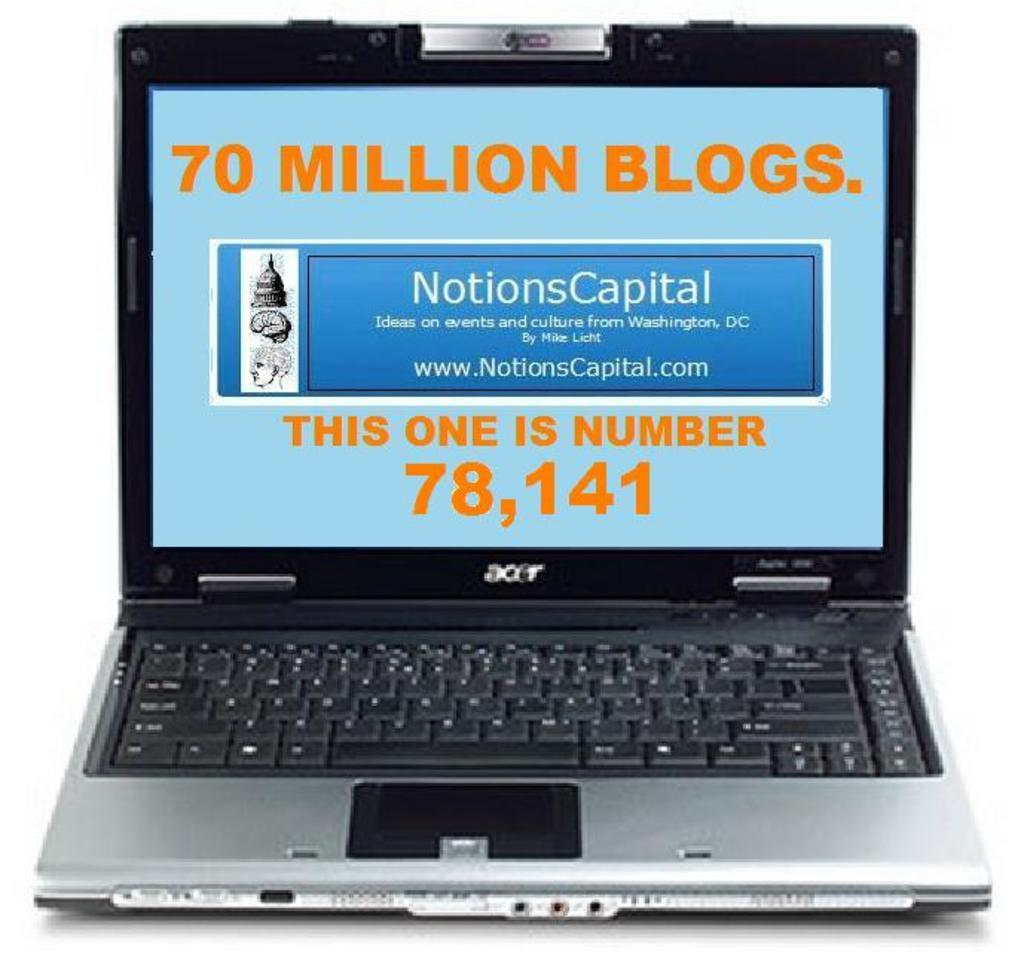<image>
Describe the image concisely. An acer laptop with a fake screen showing 70 million blogs and a link to a website. 